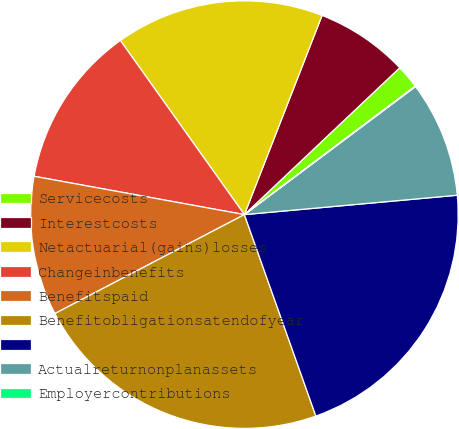Convert chart to OTSL. <chart><loc_0><loc_0><loc_500><loc_500><pie_chart><fcel>Servicecosts<fcel>Interestcosts<fcel>Netactuarial(gains)losses<fcel>Changeinbenefits<fcel>Benefitspaid<fcel>Benefitobligationsatendofyear<fcel>Unnamed: 6<fcel>Actualreturnonplanassets<fcel>Employercontributions<nl><fcel>1.79%<fcel>7.03%<fcel>15.77%<fcel>12.28%<fcel>10.53%<fcel>22.77%<fcel>21.02%<fcel>8.78%<fcel>0.04%<nl></chart> 